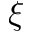Convert formula to latex. <formula><loc_0><loc_0><loc_500><loc_500>\xi</formula> 